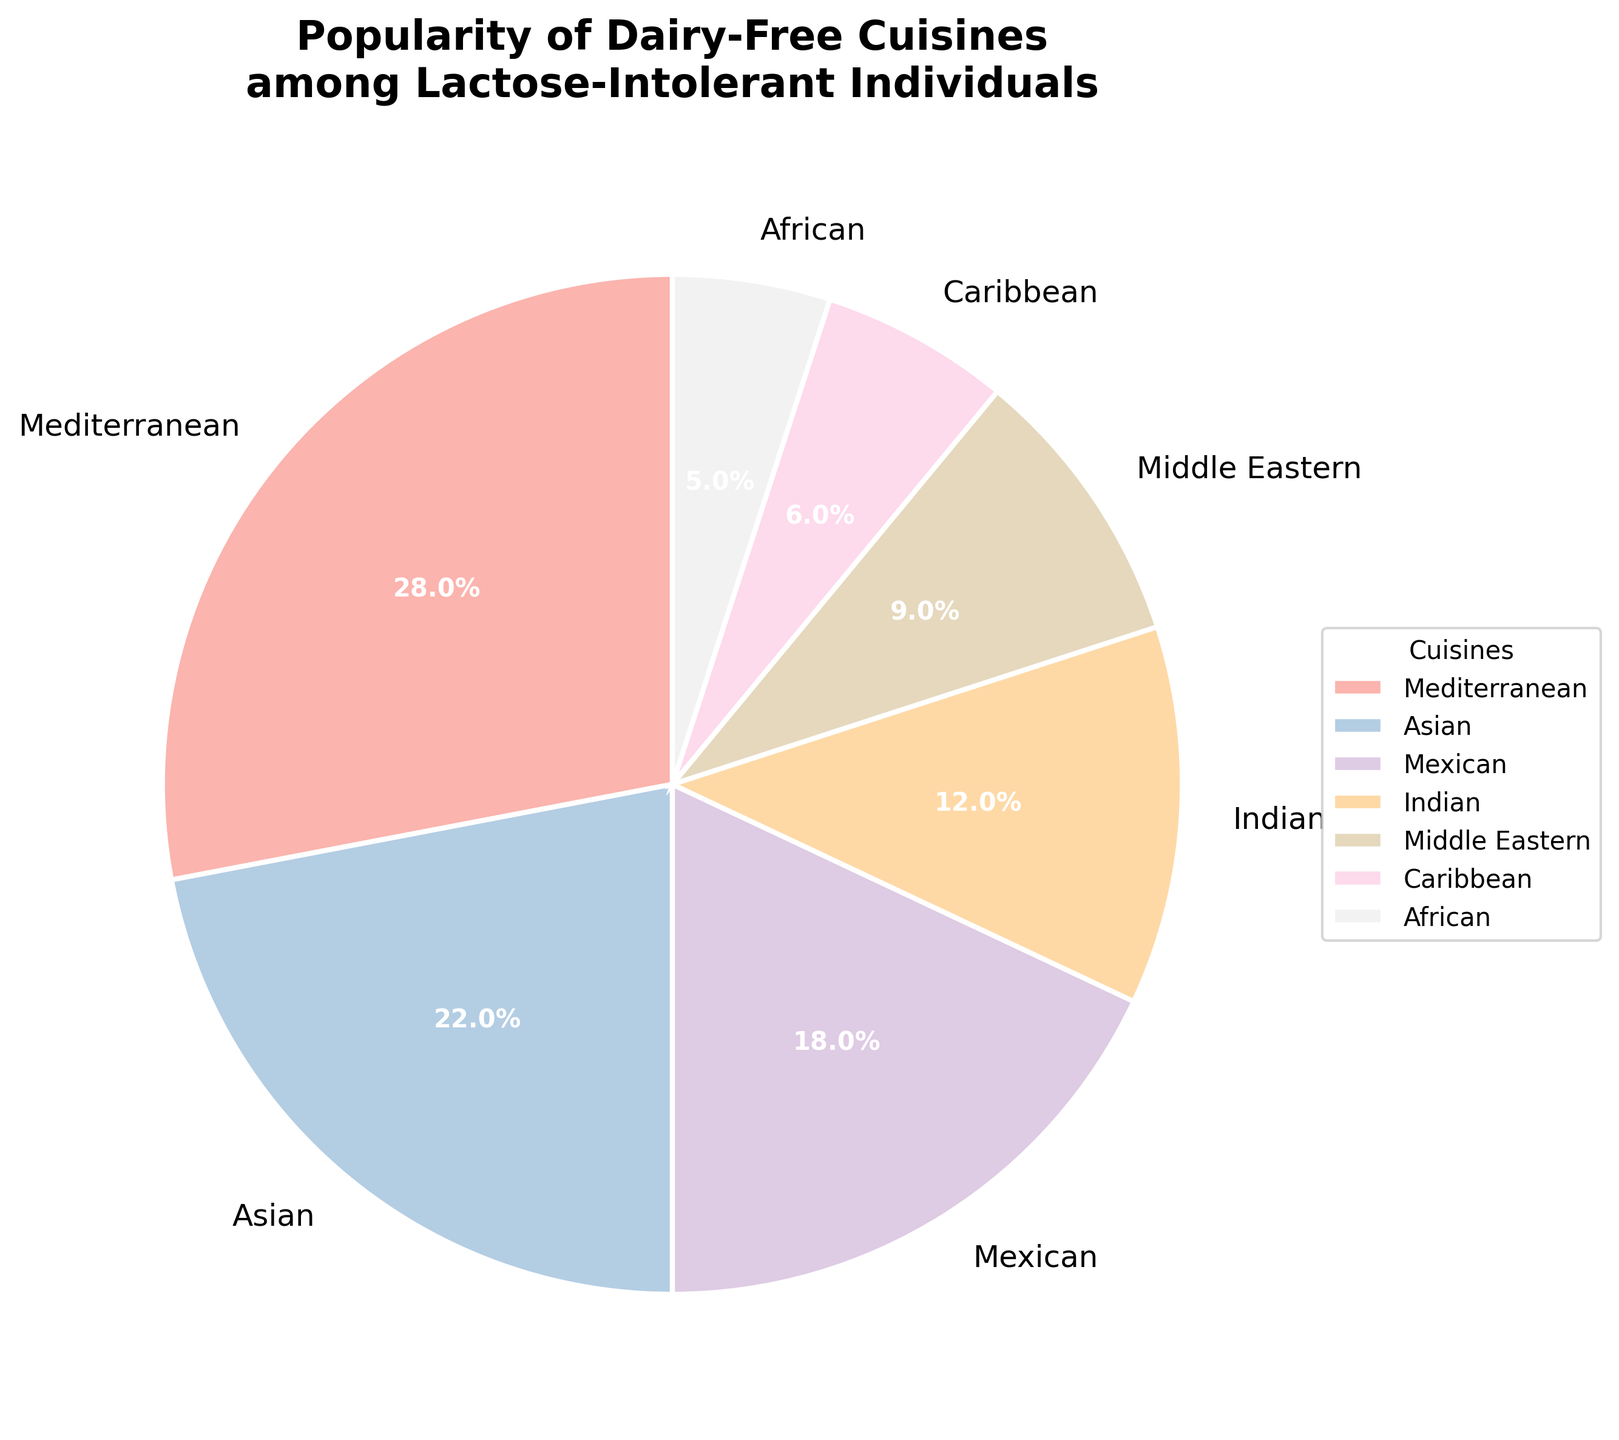Which cuisine is the most popular among lactose-intolerant individuals? The pie chart shows different cuisines and their corresponding percentages. The highest percentage in the chart is for Mediterranean cuisine at 28%.
Answer: Mediterranean Which cuisine is the least popular among lactose-intolerant individuals? The pie chart shows different cuisines and their corresponding percentages. The smallest percentage in the chart is for African cuisine at 5%.
Answer: African What are the combined percentages of Mediterranean and Asian cuisines? From the pie chart, Mediterranean cuisine is 28% and Asian cuisine is 22%. Adding these together gives 28% + 22% = 50%.
Answer: 50% Is Mexican cuisine more or less popular than Indian cuisine among lactose-intolerant individuals? According to the pie chart, Mexican cuisine is at 18%, and Indian cuisine is at 12%. Comparing these values, Mexican cuisine is more popular than Indian cuisine.
Answer: More popular Rank the cuisines from most popular to least popular based on the pie chart. The percentages from the pie chart are: Mediterranean (28%), Asian (22%), Mexican (18%), Indian (12%), Middle Eastern (9%), Caribbean (6%), and African (5%). Arranging these in descending order gives the rank.
Answer: Mediterranean, Asian, Mexican, Indian, Middle Eastern, Caribbean, African How much more popular is Mediterranean cuisine compared to Indian cuisine? Mediterranean cuisine has a percentage of 28% and Indian cuisine has 12%. The difference is 28% - 12% = 16%.
Answer: 16% What percentage of the combined favorite cuisines (Mediterranean, Asian, and Mexican) among lactose-intolerant individuals does Indian cuisine represent? Summing the top three favorites: Mediterranean (28%), Asian (22%), and Mexican (18%) gives 28% + 22% + 18% = 68%. Indian cuisine represents 12% of the total. To find the percentage of Indian cuisine in the combined favorites, use (12 / 68) * 100 which approximates to 17.6%.
Answer: 17.6% If we group Caribbean and African cuisines together, what is their combined popularity? From the pie chart, Caribbean cuisine is 6% and African cuisine is 5%. Adding these together gives 6% + 5% = 11%.
Answer: 11% Compare the popularity of Middle Eastern cuisine to the total of Caribbean and African cuisines combined. Middle Eastern cuisine has a percentage of 9%, and the total of Caribbean and African cuisines combined is 6% + 5% = 11%. Comparing these values, 9% is less than 11%.
Answer: Less popular Which cuisine has a visual attribute of being represented with the darkest color in the pie chart? The pie chart uses a pastel color palette, generally assigning the darkest shade to the segment with the highest value. Therefore, Mediterranean cuisine, having the highest percentage, is represented with the darkest color.
Answer: Mediterranean 